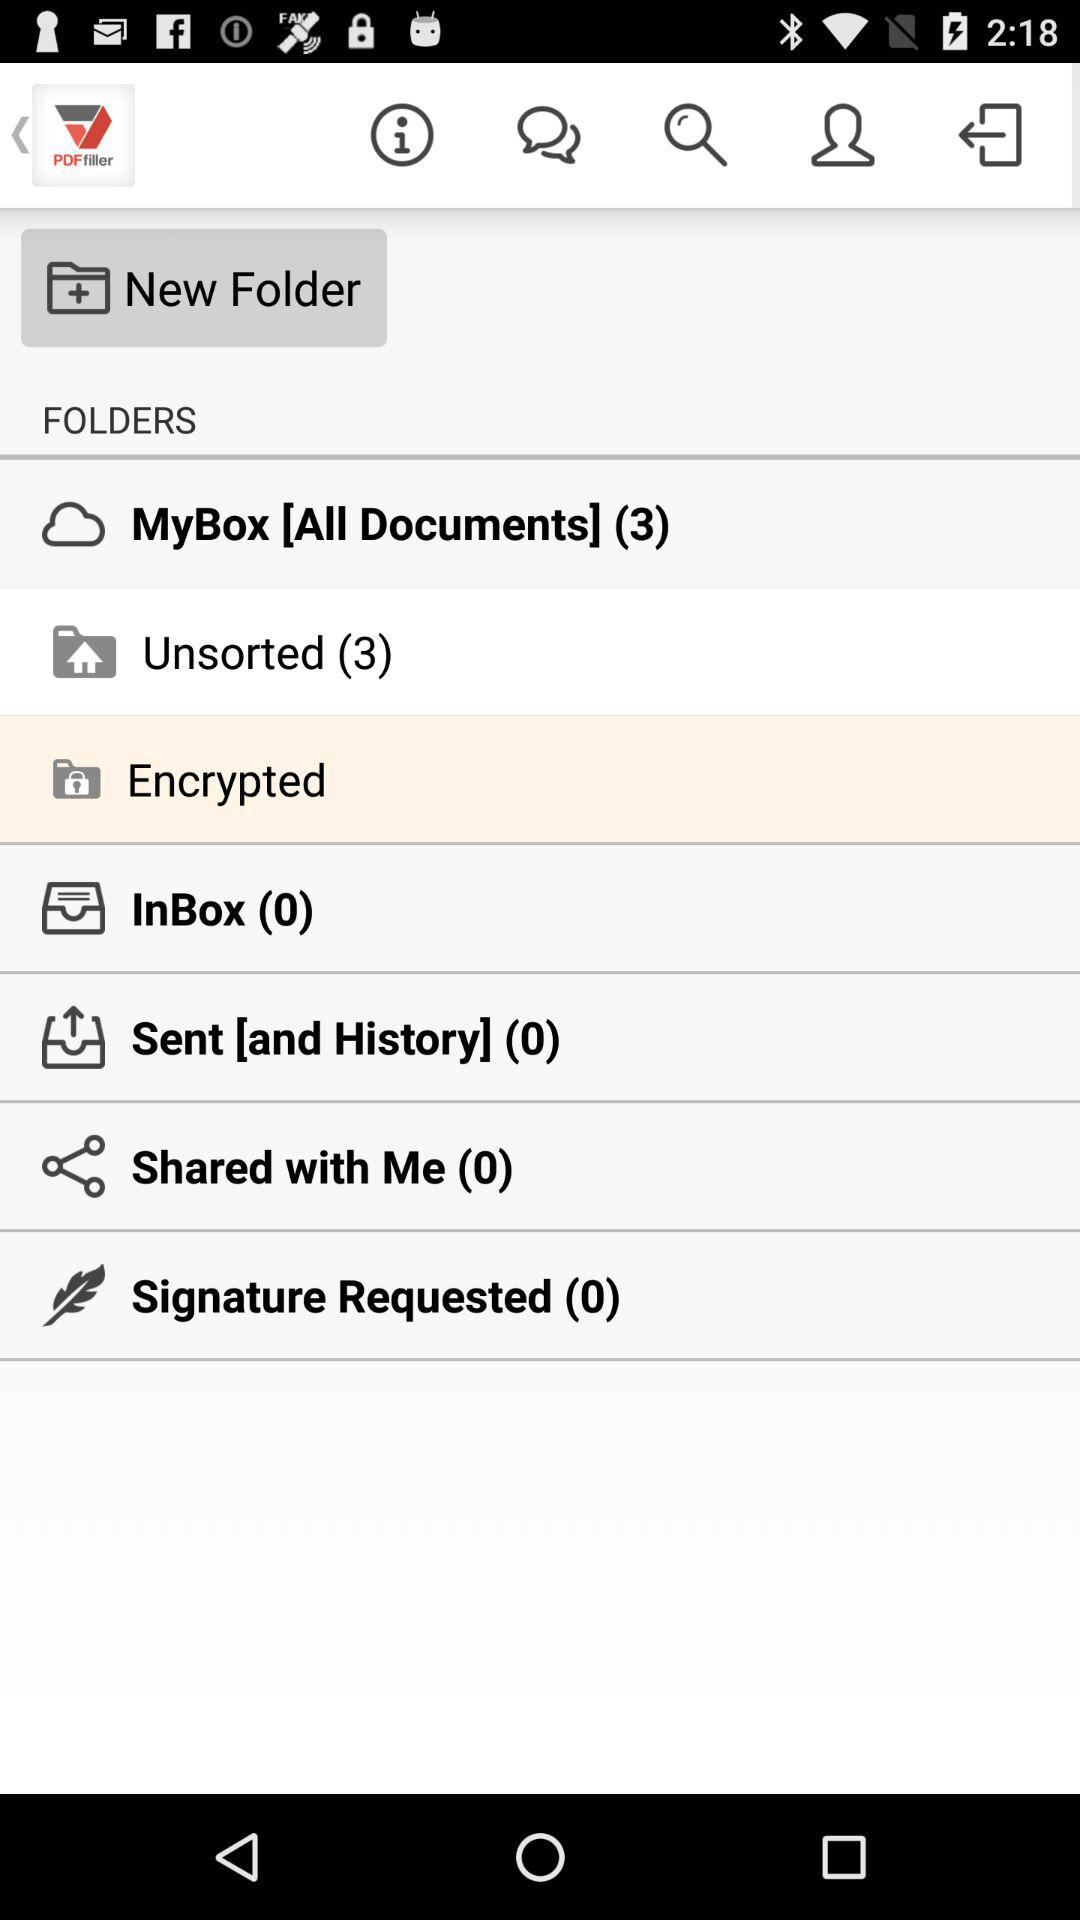How many unread messages in unsorted folder?
When the provided information is insufficient, respond with <no answer>. <no answer> 